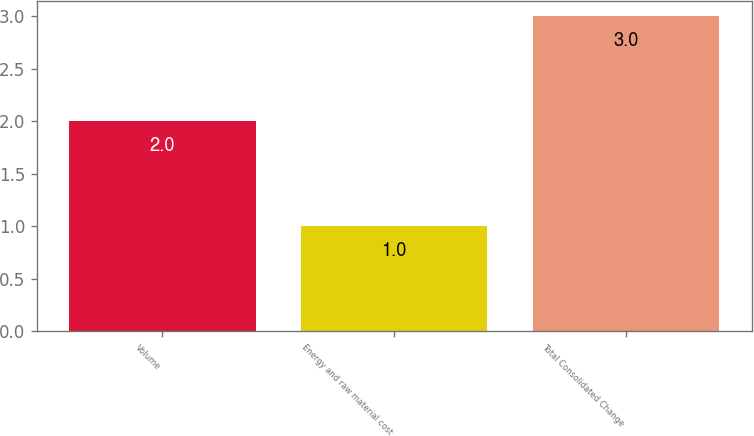Convert chart. <chart><loc_0><loc_0><loc_500><loc_500><bar_chart><fcel>Volume<fcel>Energy and raw material cost<fcel>Total Consolidated Change<nl><fcel>2<fcel>1<fcel>3<nl></chart> 